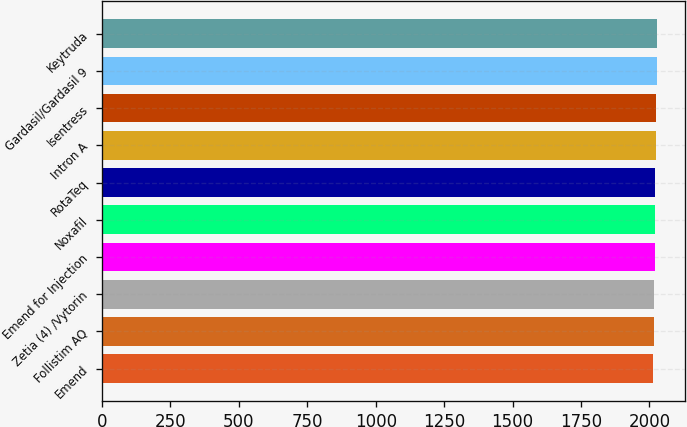<chart> <loc_0><loc_0><loc_500><loc_500><bar_chart><fcel>Emend<fcel>Follistim AQ<fcel>Zetia (4) /Vytorin<fcel>Emend for Injection<fcel>Noxafil<fcel>RotaTeq<fcel>Intron A<fcel>Isentress<fcel>Gardasil/Gardasil 9<fcel>Keytruda<nl><fcel>2015<fcel>2016.4<fcel>2017.8<fcel>2019.2<fcel>2020.6<fcel>2022<fcel>2023.4<fcel>2024.8<fcel>2028<fcel>2029.4<nl></chart> 